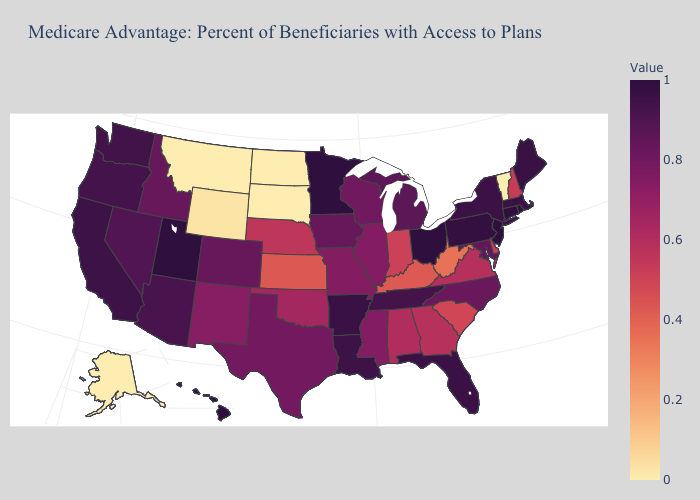Does Ohio have the lowest value in the MidWest?
Be succinct. No. Which states have the highest value in the USA?
Be succinct. Connecticut, Hawaii, Minnesota, New Jersey, Ohio, Rhode Island, Utah. 